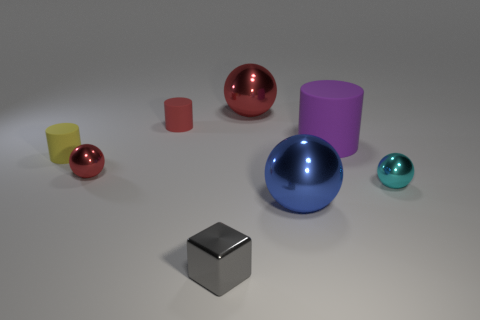Add 2 rubber cylinders. How many objects exist? 10 Subtract all cubes. How many objects are left? 7 Add 1 metallic things. How many metallic things are left? 6 Add 6 purple rubber objects. How many purple rubber objects exist? 7 Subtract 0 yellow balls. How many objects are left? 8 Subtract all small gray metal things. Subtract all small gray rubber things. How many objects are left? 7 